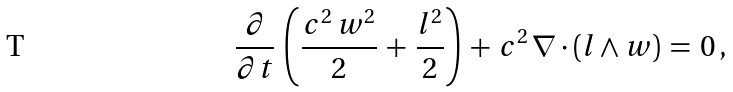Convert formula to latex. <formula><loc_0><loc_0><loc_500><loc_500>\frac { \partial } { \partial t } \, \left ( \frac { c ^ { 2 } \, { w } ^ { 2 } } { 2 } \, + \, \frac { { l } ^ { 2 } } { 2 } \right ) \, + \, c ^ { 2 } \, \nabla \cdot ( { l } \wedge { w } ) \, = \, 0 \, ,</formula> 